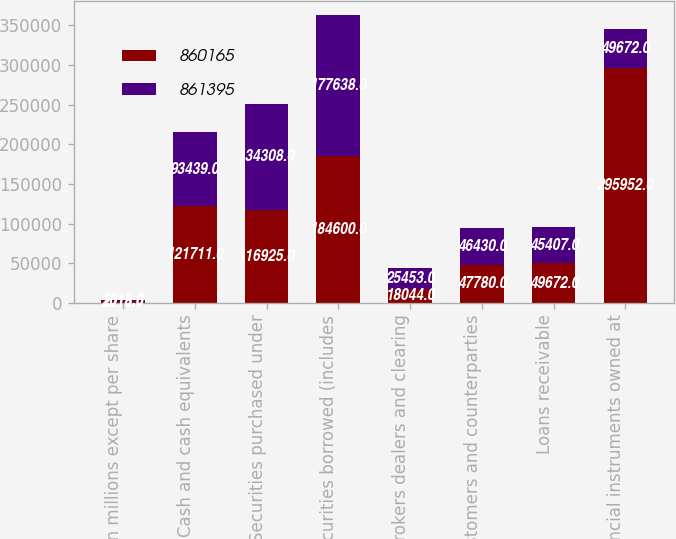<chart> <loc_0><loc_0><loc_500><loc_500><stacked_bar_chart><ecel><fcel>in millions except per share<fcel>Cash and cash equivalents<fcel>Securities purchased under<fcel>Securities borrowed (includes<fcel>Brokers dealers and clearing<fcel>Customers and counterparties<fcel>Loans receivable<fcel>Financial instruments owned at<nl><fcel>860165<fcel>2016<fcel>121711<fcel>116925<fcel>184600<fcel>18044<fcel>47780<fcel>49672<fcel>295952<nl><fcel>861395<fcel>2015<fcel>93439<fcel>134308<fcel>177638<fcel>25453<fcel>46430<fcel>45407<fcel>49672<nl></chart> 